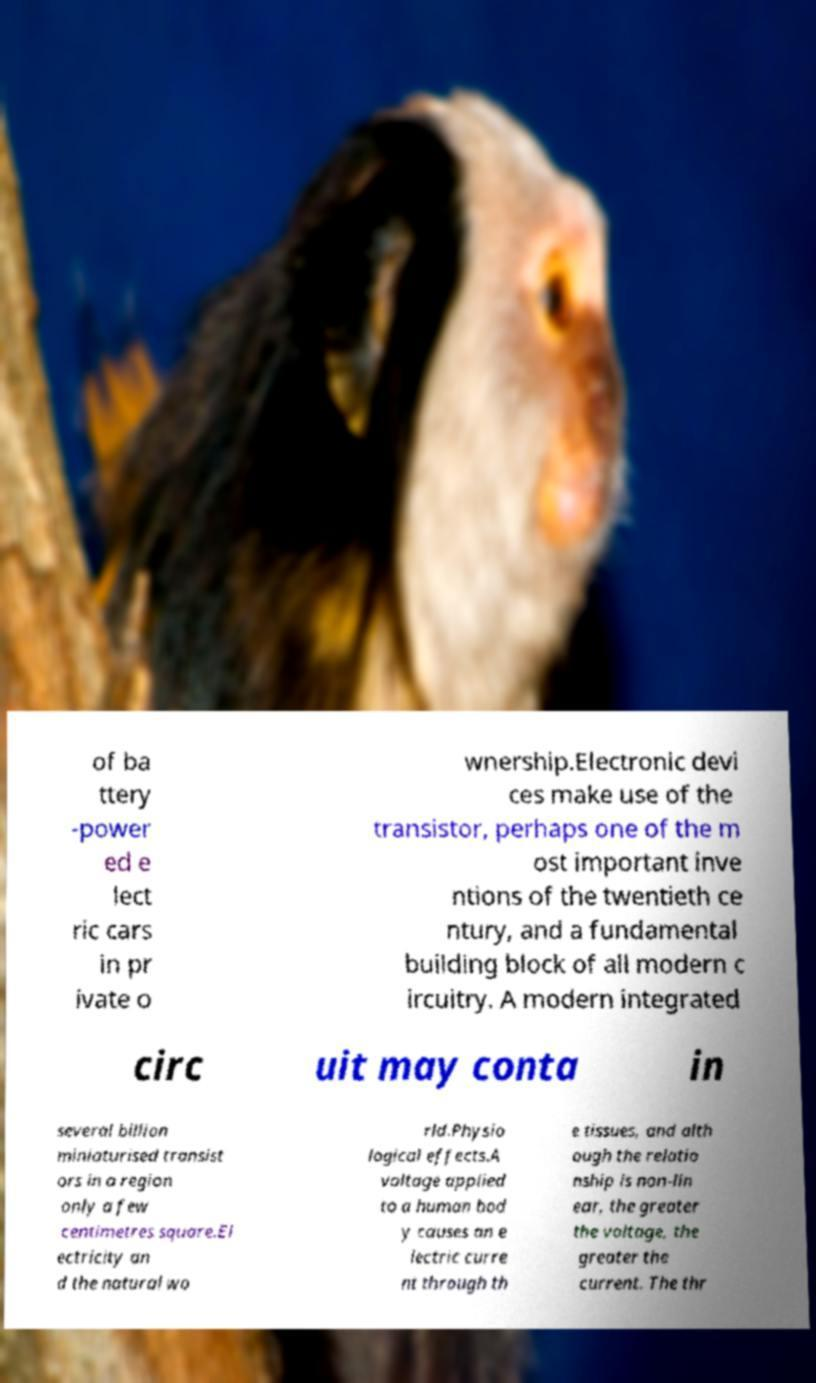Can you read and provide the text displayed in the image?This photo seems to have some interesting text. Can you extract and type it out for me? of ba ttery -power ed e lect ric cars in pr ivate o wnership.Electronic devi ces make use of the transistor, perhaps one of the m ost important inve ntions of the twentieth ce ntury, and a fundamental building block of all modern c ircuitry. A modern integrated circ uit may conta in several billion miniaturised transist ors in a region only a few centimetres square.El ectricity an d the natural wo rld.Physio logical effects.A voltage applied to a human bod y causes an e lectric curre nt through th e tissues, and alth ough the relatio nship is non-lin ear, the greater the voltage, the greater the current. The thr 